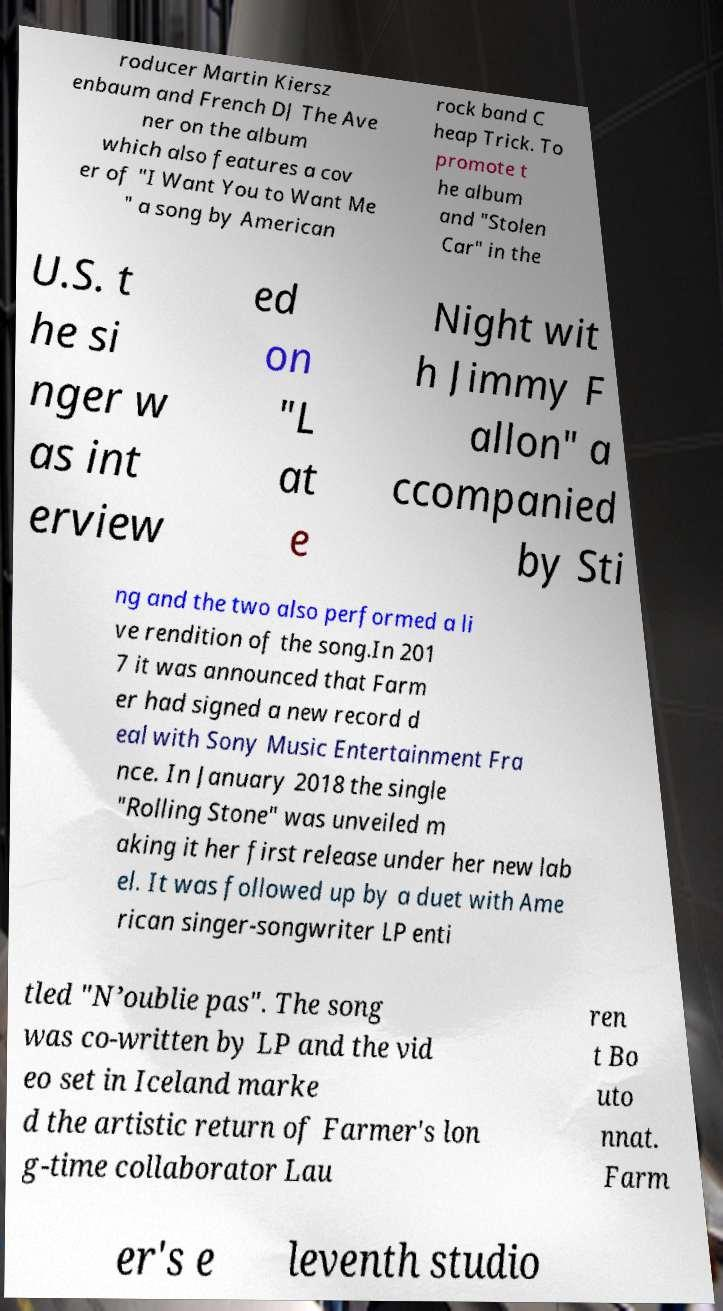Could you extract and type out the text from this image? roducer Martin Kiersz enbaum and French DJ The Ave ner on the album which also features a cov er of "I Want You to Want Me " a song by American rock band C heap Trick. To promote t he album and "Stolen Car" in the U.S. t he si nger w as int erview ed on "L at e Night wit h Jimmy F allon" a ccompanied by Sti ng and the two also performed a li ve rendition of the song.In 201 7 it was announced that Farm er had signed a new record d eal with Sony Music Entertainment Fra nce. In January 2018 the single "Rolling Stone" was unveiled m aking it her first release under her new lab el. It was followed up by a duet with Ame rican singer-songwriter LP enti tled "N’oublie pas". The song was co-written by LP and the vid eo set in Iceland marke d the artistic return of Farmer's lon g-time collaborator Lau ren t Bo uto nnat. Farm er's e leventh studio 